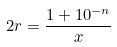Convert formula to latex. <formula><loc_0><loc_0><loc_500><loc_500>2 r = \frac { 1 + 1 0 ^ { - n } } { x }</formula> 